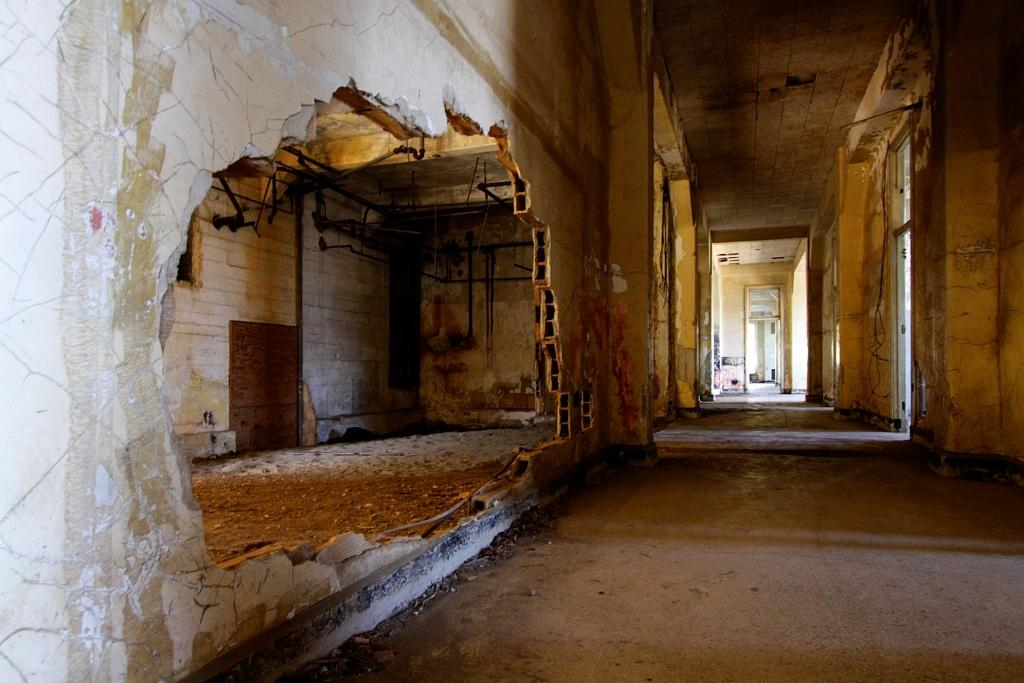What type of location is depicted in the image? The image shows an inside view of a house. What materials can be seen in the image? There are iron rods and cables visible in the image. Can you describe any other items in the image? There are other unspecified items in the image. What type of pizzas are being attacked by the board in the image? There are no pizzas or boards present in the image. 